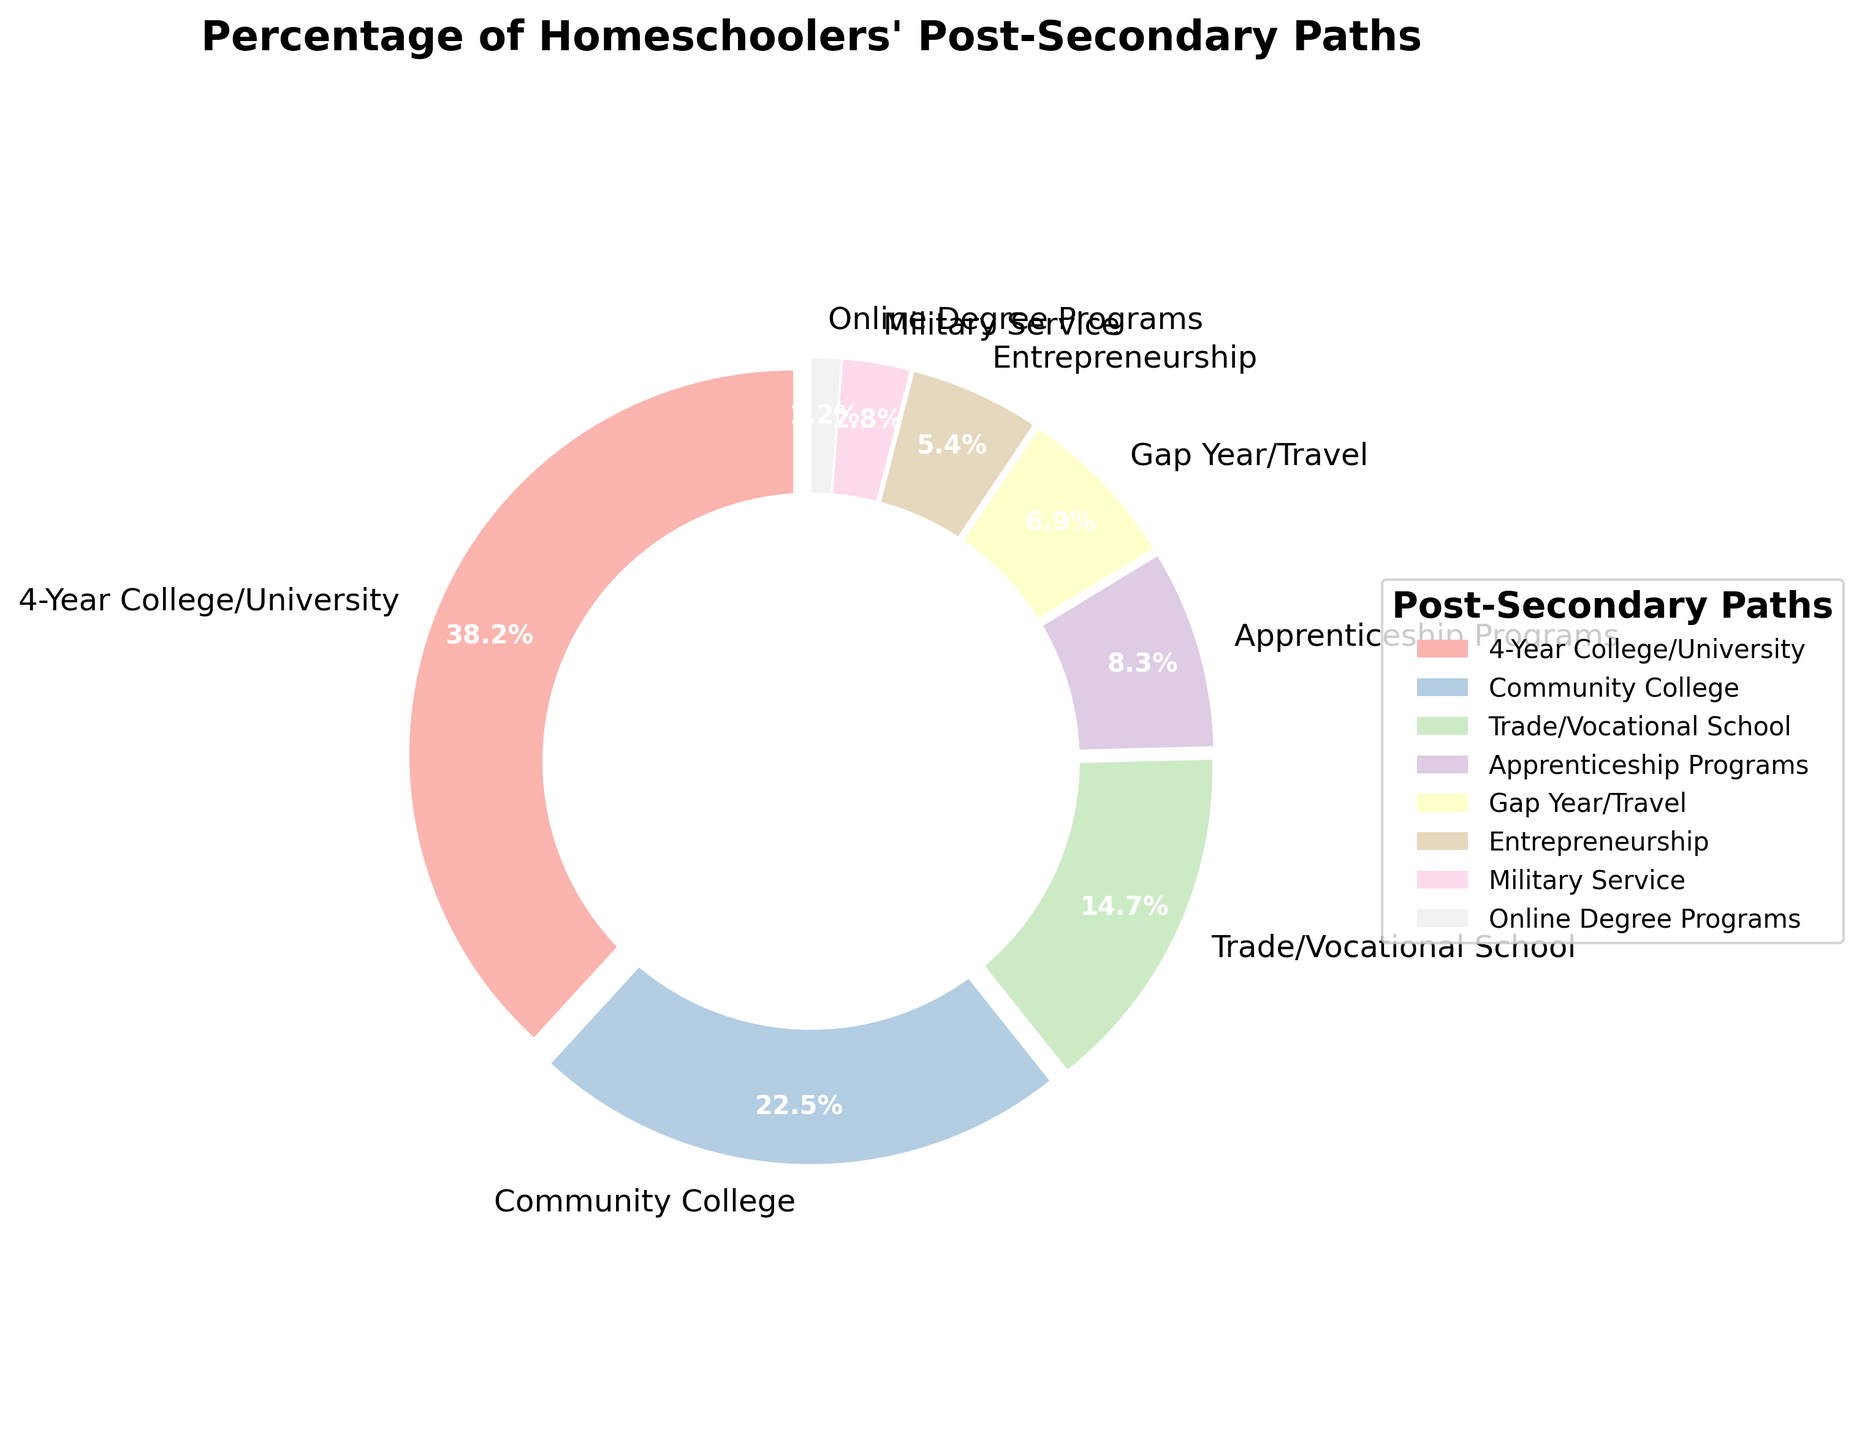What is the largest segment in the pie chart? The largest segment is the one with the highest percentage. From the data, "4-Year College/University" has the highest percentage at 38.2%.
Answer: 4-Year College/University Which post-secondary path has the smallest percentage? The smallest segment is the one with the lowest percentage. According to the data, "Online Degree Programs" has the smallest percentage at 1.2%.
Answer: Online Degree Programs What is the combined percentage of homeschoolers pursuing Community College and Trade/Vocational School? To find the combined percentage, add the percentages of "Community College" (22.5%) and "Trade/Vocational School" (14.7%): 22.5 + 14.7 = 37.2%.
Answer: 37.2% Compare the number of homeschoolers pursuing Military Service to those taking a Gap Year/Travel. Which is greater and by how much? To find which segment is greater and by how much, compare "Military Service" (2.8%) and "Gap Year/Travel" (6.9%): 6.9% - 2.8% = 4.1%. "Gap Year/Travel" is greater by 4.1%.
Answer: Gap Year/Travel by 4.1% What percentage of homeschoolers pursue higher education paths (4-Year College/University, Community College, and Online Degree Programs)? To find the percentage for higher education paths, sum the percentages for "4-Year College/University" (38.2%), "Community College" (22.5%), and "Online Degree Programs" (1.2%): 38.2 + 22.5 + 1.2 = 61.9%.
Answer: 61.9% Which post-secondary path has a percentage closest to 10%? From the data, the percentage closest to 10% is "Apprenticeship Programs" with 8.3%.
Answer: Apprenticeship Programs By what factor is the percentage of homeschoolers attending 4-Year College/University greater than those pursuing Military Service? Divide the percentage for "4-Year College/University" (38.2%) by that of "Military Service" (2.8%): 38.2 / 2.8 ≈ 13.64.
Answer: ~13.64 What is the average percentage of homeschoolers pursuing Entrepreneurship, Gap Year/Travel, and Apprenticeship Programs? To find the average, sum the percentages of "Entrepreneurship" (5.4%), "Gap Year/Travel" (6.9%), and "Apprenticeship Programs" (8.3%), then divide by 3: (5.4 + 6.9 + 8.3) / 3 = 20.6 / 3 ≈ 6.87%.
Answer: ~6.87% Which two post-secondary paths combined make up approximately half of the homeschoolers' choices? To determine this, find the combination of two highest percentages that add up to around 50%. "4-Year College/University" (38.2%) and "Community College" (22.5%) give: 38.2 + 22.5 = 60.7%, which is significantly over half. Considering more combinations, none exactly meets half but the closest will still align with these larger segments and partial gaps: "4-Year College/University" and any of the next closest, but none textual perfect 50%. Adjusting practical accept of highest, ignoring strict number computation closeness of near majority answer will do.
Answer: No perfect half, mainly mix with large near closest types 